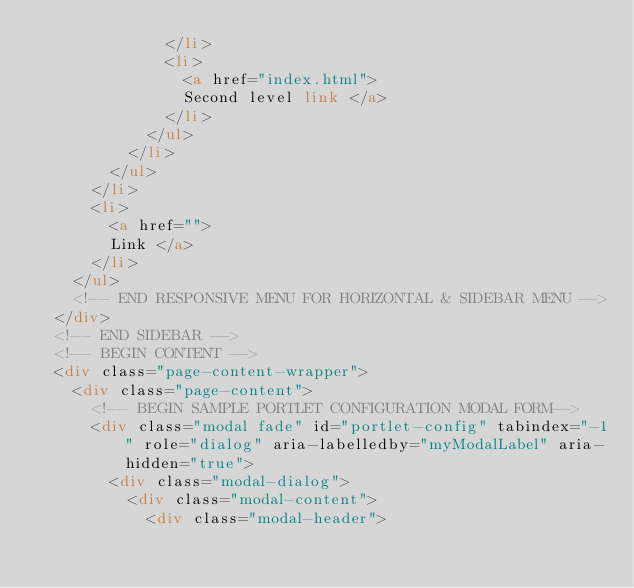<code> <loc_0><loc_0><loc_500><loc_500><_HTML_>							</li>
							<li>
								<a href="index.html">
								Second level link </a>
							</li>
						</ul>
					</li>
				</ul>
			</li>
			<li>
				<a href="">
				Link </a>
			</li>
		</ul>
		<!-- END RESPONSIVE MENU FOR HORIZONTAL & SIDEBAR MENU -->
	</div>
	<!-- END SIDEBAR -->
	<!-- BEGIN CONTENT -->
	<div class="page-content-wrapper">
		<div class="page-content">
			<!-- BEGIN SAMPLE PORTLET CONFIGURATION MODAL FORM-->
			<div class="modal fade" id="portlet-config" tabindex="-1" role="dialog" aria-labelledby="myModalLabel" aria-hidden="true">
				<div class="modal-dialog">
					<div class="modal-content">
						<div class="modal-header"></code> 